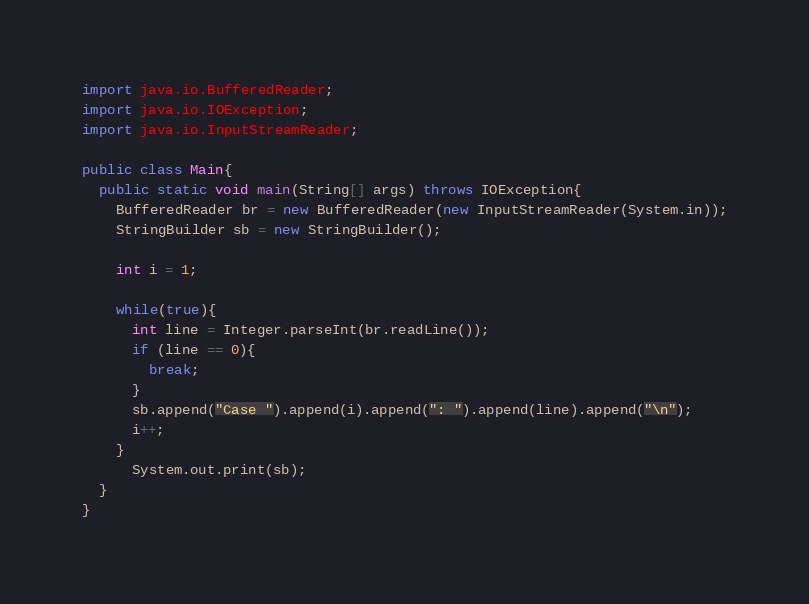<code> <loc_0><loc_0><loc_500><loc_500><_Java_>import java.io.BufferedReader;
import java.io.IOException;
import java.io.InputStreamReader;

public class Main{
  public static void main(String[] args) throws IOException{
    BufferedReader br = new BufferedReader(new InputStreamReader(System.in));
    StringBuilder sb = new StringBuilder();

    int i = 1;

    while(true){
      int line = Integer.parseInt(br.readLine());
      if (line == 0){
        break;
      }
      sb.append("Case ").append(i).append(": ").append(line).append("\n");
      i++;
    }
      System.out.print(sb);
  }
}</code> 